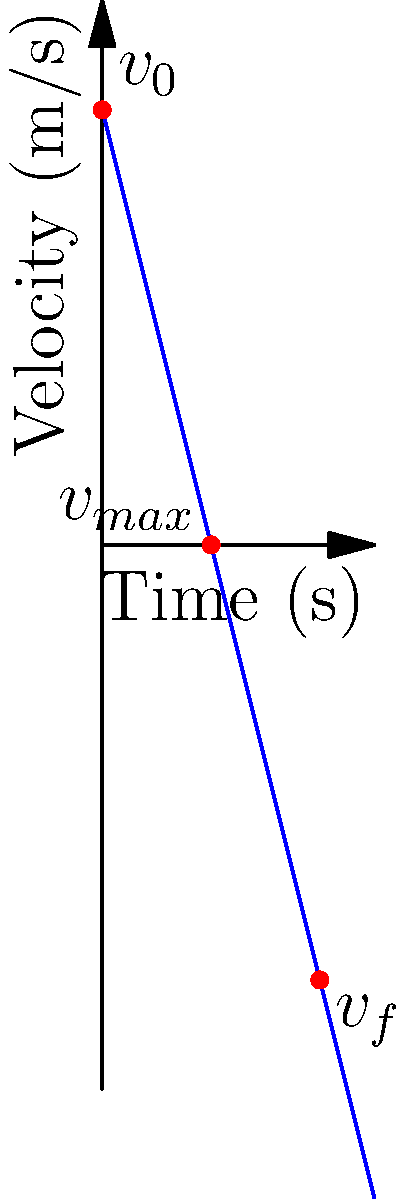In a 2D physics simulation of a projectile affected by gravity, the graph shows the vertical velocity of an object over time. Given that the initial velocity ($v_0$) is 8 m/s upward, what is the acceleration due to gravity ($g$) in this simulation? To determine the acceleration due to gravity in this simulation, we can follow these steps:

1. Identify the key information from the graph:
   - Initial velocity ($v_0$) = 8 m/s (upward)
   - Time to reach maximum height (when velocity becomes 0) = 2 seconds
   - Final velocity at 4 seconds ($v_f$) = -8 m/s

2. Use the equation for velocity under constant acceleration:
   $v = v_0 + at$, where $a$ is the acceleration (in this case, $-g$)

3. At the point of maximum height (t = 2s, v = 0):
   $0 = 8 + (-g)(2)$
   $g = 4$ m/s²

4. Verify using the final velocity at 4 seconds:
   $-8 = 8 + (-4)(4)$
   $-8 = 8 - 16$
   $-8 = -8$ (This confirms our calculation)

5. The negative sign indicates that the acceleration is downward, which is consistent with gravity.

Therefore, the acceleration due to gravity in this simulation is 4 m/s².
Answer: 4 m/s² 